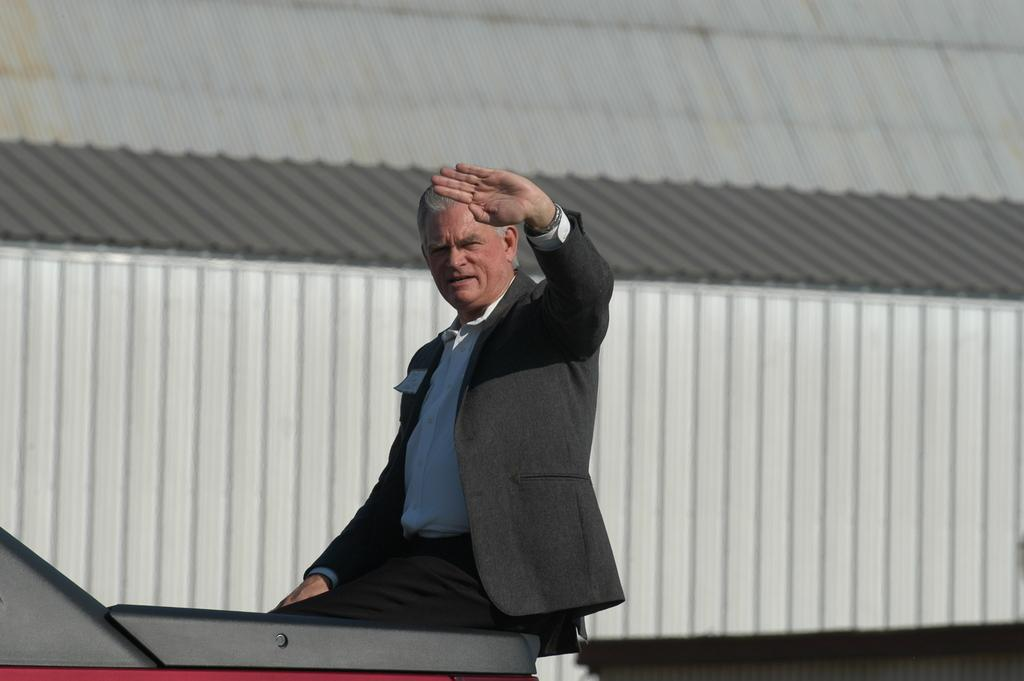What is the person in the image doing? There is a person sitting on a vehicle in the image. What can be seen in the background of the image? There is a shed in the background of the image. Can you tell me how many bats are hanging from the person's thumb in the image? There are no bats present in the image, and the person's thumb is not visible. 